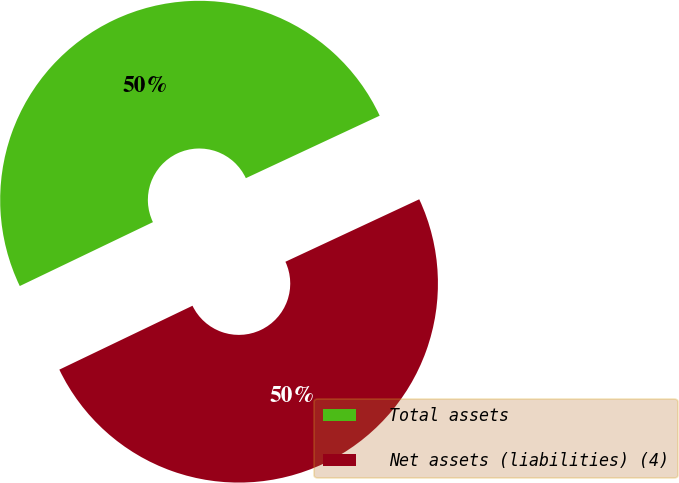Convert chart. <chart><loc_0><loc_0><loc_500><loc_500><pie_chart><fcel>Total assets<fcel>Net assets (liabilities) (4)<nl><fcel>50.17%<fcel>49.83%<nl></chart> 